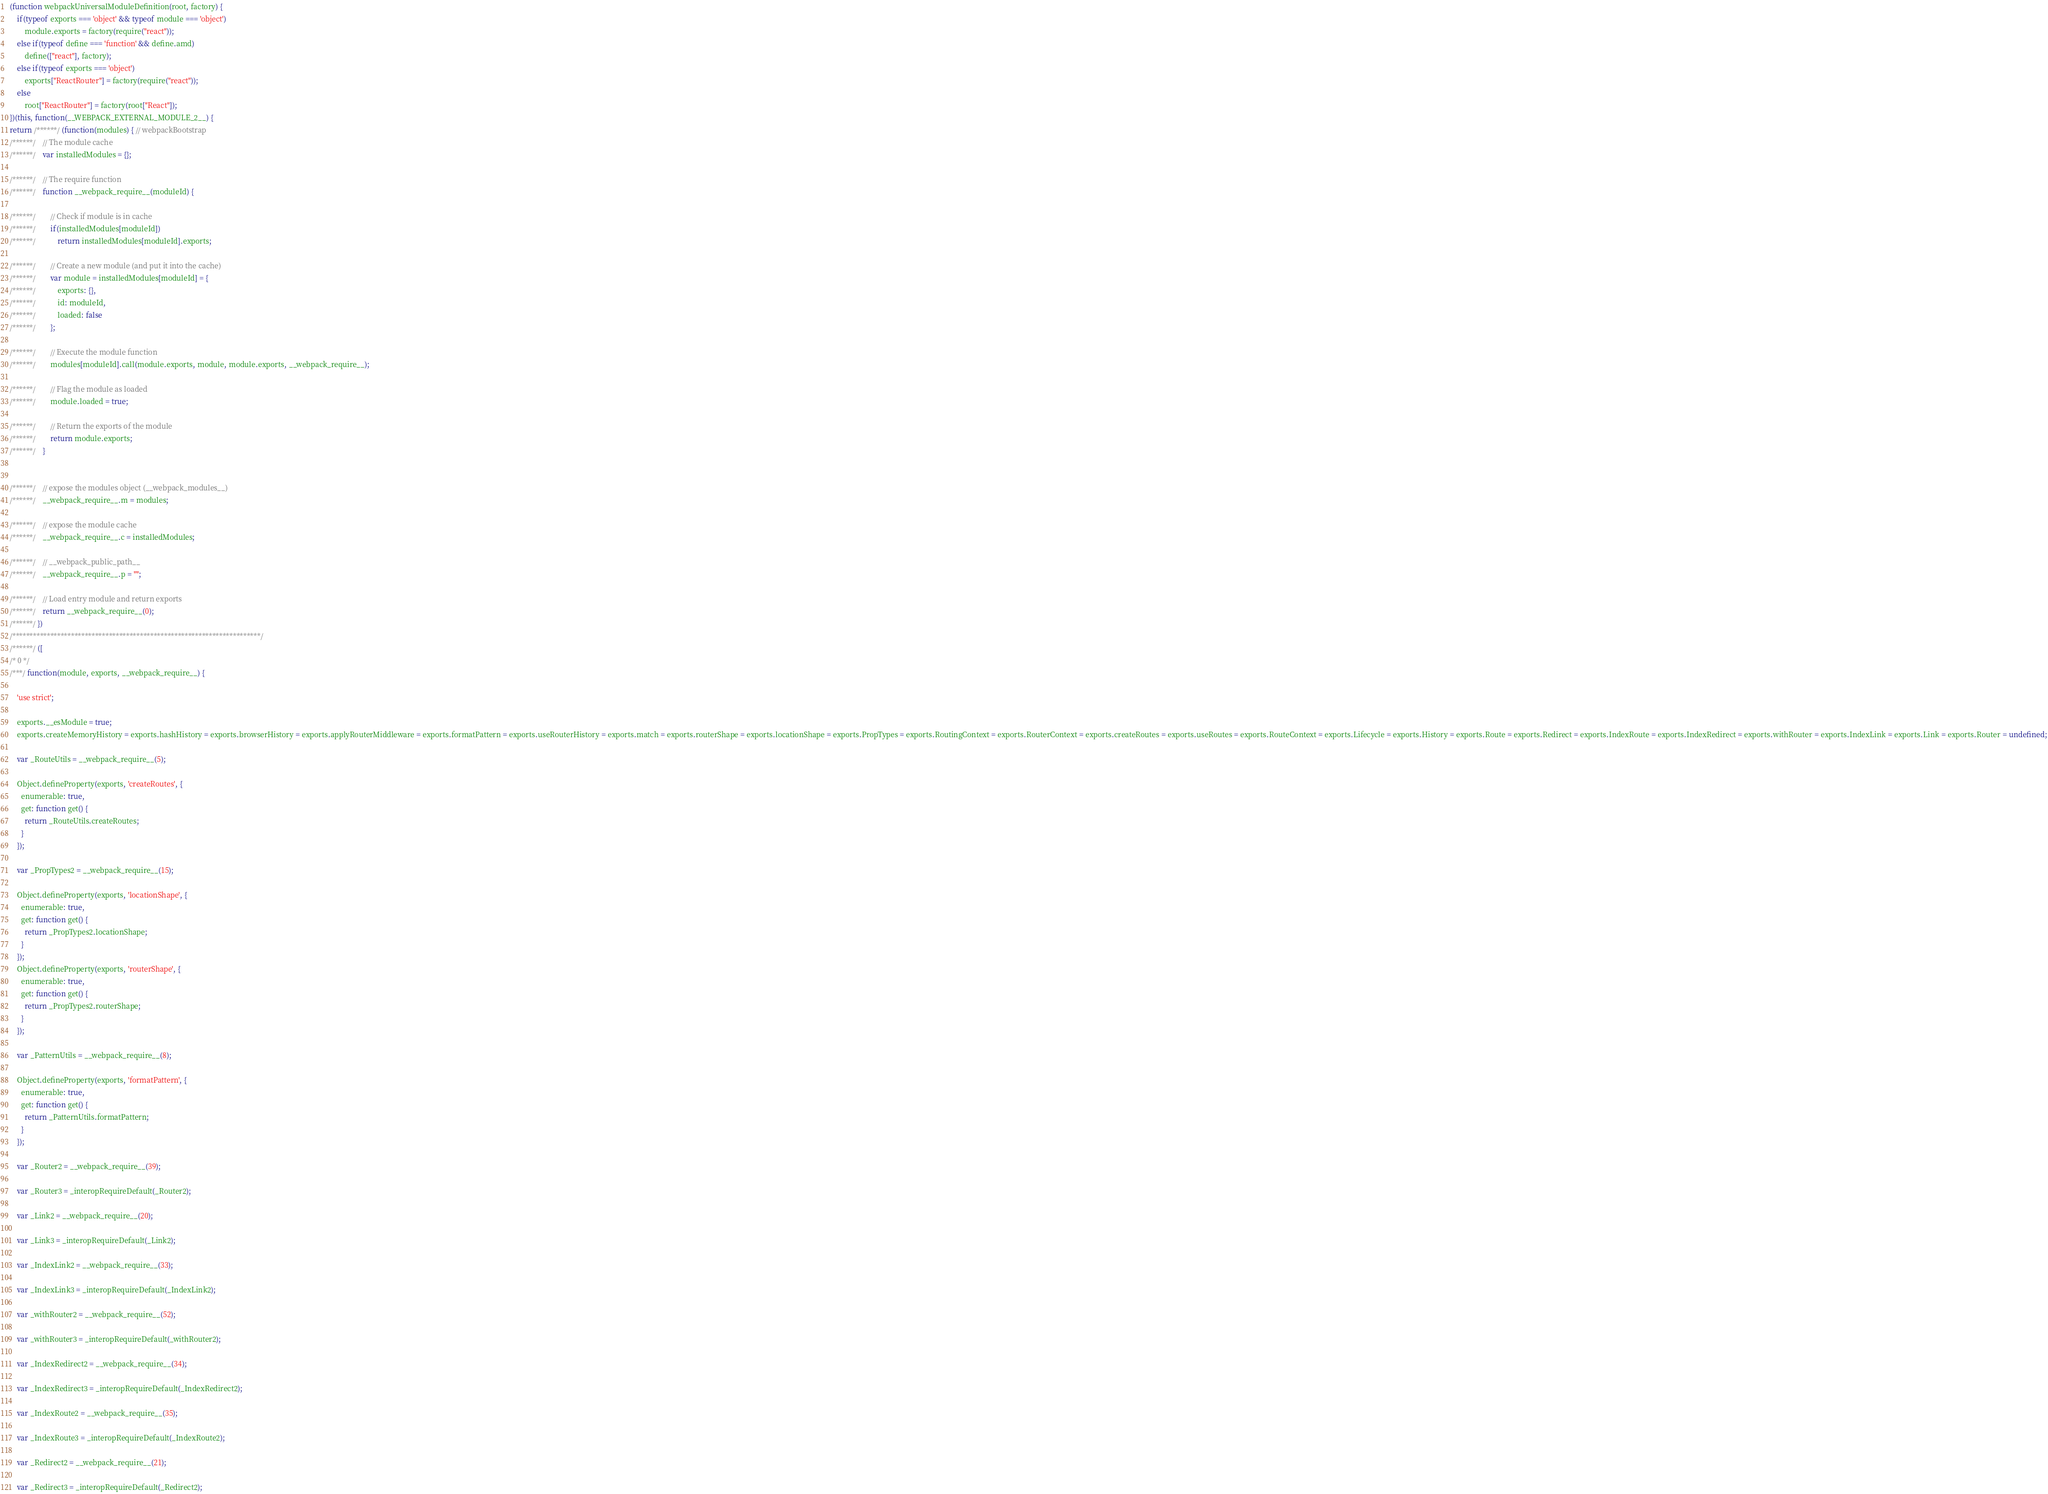Convert code to text. <code><loc_0><loc_0><loc_500><loc_500><_JavaScript_>(function webpackUniversalModuleDefinition(root, factory) {
	if(typeof exports === 'object' && typeof module === 'object')
		module.exports = factory(require("react"));
	else if(typeof define === 'function' && define.amd)
		define(["react"], factory);
	else if(typeof exports === 'object')
		exports["ReactRouter"] = factory(require("react"));
	else
		root["ReactRouter"] = factory(root["React"]);
})(this, function(__WEBPACK_EXTERNAL_MODULE_2__) {
return /******/ (function(modules) { // webpackBootstrap
/******/ 	// The module cache
/******/ 	var installedModules = {};

/******/ 	// The require function
/******/ 	function __webpack_require__(moduleId) {

/******/ 		// Check if module is in cache
/******/ 		if(installedModules[moduleId])
/******/ 			return installedModules[moduleId].exports;

/******/ 		// Create a new module (and put it into the cache)
/******/ 		var module = installedModules[moduleId] = {
/******/ 			exports: {},
/******/ 			id: moduleId,
/******/ 			loaded: false
/******/ 		};

/******/ 		// Execute the module function
/******/ 		modules[moduleId].call(module.exports, module, module.exports, __webpack_require__);

/******/ 		// Flag the module as loaded
/******/ 		module.loaded = true;

/******/ 		// Return the exports of the module
/******/ 		return module.exports;
/******/ 	}


/******/ 	// expose the modules object (__webpack_modules__)
/******/ 	__webpack_require__.m = modules;

/******/ 	// expose the module cache
/******/ 	__webpack_require__.c = installedModules;

/******/ 	// __webpack_public_path__
/******/ 	__webpack_require__.p = "";

/******/ 	// Load entry module and return exports
/******/ 	return __webpack_require__(0);
/******/ })
/************************************************************************/
/******/ ([
/* 0 */
/***/ function(module, exports, __webpack_require__) {

	'use strict';

	exports.__esModule = true;
	exports.createMemoryHistory = exports.hashHistory = exports.browserHistory = exports.applyRouterMiddleware = exports.formatPattern = exports.useRouterHistory = exports.match = exports.routerShape = exports.locationShape = exports.PropTypes = exports.RoutingContext = exports.RouterContext = exports.createRoutes = exports.useRoutes = exports.RouteContext = exports.Lifecycle = exports.History = exports.Route = exports.Redirect = exports.IndexRoute = exports.IndexRedirect = exports.withRouter = exports.IndexLink = exports.Link = exports.Router = undefined;

	var _RouteUtils = __webpack_require__(5);

	Object.defineProperty(exports, 'createRoutes', {
	  enumerable: true,
	  get: function get() {
	    return _RouteUtils.createRoutes;
	  }
	});

	var _PropTypes2 = __webpack_require__(15);

	Object.defineProperty(exports, 'locationShape', {
	  enumerable: true,
	  get: function get() {
	    return _PropTypes2.locationShape;
	  }
	});
	Object.defineProperty(exports, 'routerShape', {
	  enumerable: true,
	  get: function get() {
	    return _PropTypes2.routerShape;
	  }
	});

	var _PatternUtils = __webpack_require__(8);

	Object.defineProperty(exports, 'formatPattern', {
	  enumerable: true,
	  get: function get() {
	    return _PatternUtils.formatPattern;
	  }
	});

	var _Router2 = __webpack_require__(39);

	var _Router3 = _interopRequireDefault(_Router2);

	var _Link2 = __webpack_require__(20);

	var _Link3 = _interopRequireDefault(_Link2);

	var _IndexLink2 = __webpack_require__(33);

	var _IndexLink3 = _interopRequireDefault(_IndexLink2);

	var _withRouter2 = __webpack_require__(52);

	var _withRouter3 = _interopRequireDefault(_withRouter2);

	var _IndexRedirect2 = __webpack_require__(34);

	var _IndexRedirect3 = _interopRequireDefault(_IndexRedirect2);

	var _IndexRoute2 = __webpack_require__(35);

	var _IndexRoute3 = _interopRequireDefault(_IndexRoute2);

	var _Redirect2 = __webpack_require__(21);

	var _Redirect3 = _interopRequireDefault(_Redirect2);
</code> 